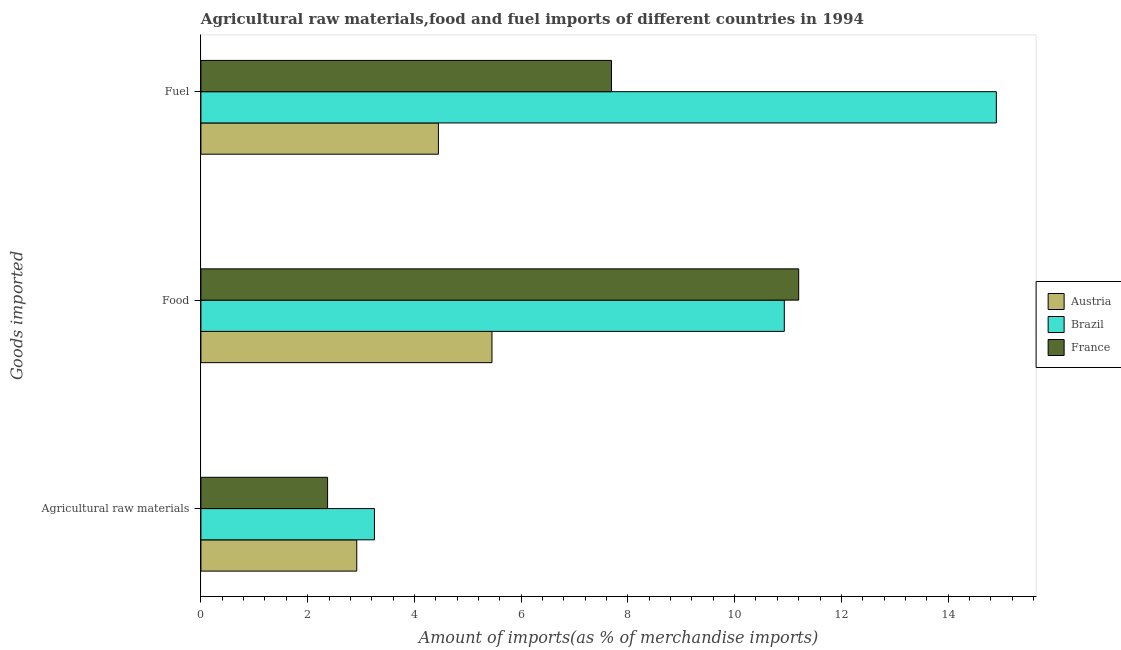How many different coloured bars are there?
Provide a succinct answer. 3. How many groups of bars are there?
Your response must be concise. 3. Are the number of bars on each tick of the Y-axis equal?
Your answer should be very brief. Yes. How many bars are there on the 1st tick from the top?
Offer a very short reply. 3. How many bars are there on the 1st tick from the bottom?
Give a very brief answer. 3. What is the label of the 1st group of bars from the top?
Give a very brief answer. Fuel. What is the percentage of food imports in Brazil?
Offer a very short reply. 10.93. Across all countries, what is the maximum percentage of food imports?
Ensure brevity in your answer.  11.2. Across all countries, what is the minimum percentage of raw materials imports?
Provide a succinct answer. 2.37. In which country was the percentage of food imports maximum?
Keep it short and to the point. France. In which country was the percentage of fuel imports minimum?
Offer a terse response. Austria. What is the total percentage of raw materials imports in the graph?
Make the answer very short. 8.55. What is the difference between the percentage of food imports in France and that in Brazil?
Offer a very short reply. 0.27. What is the difference between the percentage of food imports in France and the percentage of fuel imports in Austria?
Your answer should be compact. 6.75. What is the average percentage of food imports per country?
Give a very brief answer. 9.2. What is the difference between the percentage of food imports and percentage of fuel imports in France?
Provide a succinct answer. 3.51. What is the ratio of the percentage of food imports in Brazil to that in Austria?
Give a very brief answer. 2. Is the percentage of food imports in Brazil less than that in France?
Your response must be concise. Yes. What is the difference between the highest and the second highest percentage of fuel imports?
Ensure brevity in your answer.  7.21. What is the difference between the highest and the lowest percentage of fuel imports?
Provide a succinct answer. 10.45. Is the sum of the percentage of food imports in Brazil and France greater than the maximum percentage of raw materials imports across all countries?
Offer a very short reply. Yes. What does the 2nd bar from the top in Agricultural raw materials represents?
Provide a short and direct response. Brazil. How many bars are there?
Keep it short and to the point. 9. What is the difference between two consecutive major ticks on the X-axis?
Give a very brief answer. 2. Are the values on the major ticks of X-axis written in scientific E-notation?
Provide a short and direct response. No. Does the graph contain any zero values?
Keep it short and to the point. No. Does the graph contain grids?
Your answer should be very brief. No. Where does the legend appear in the graph?
Your answer should be very brief. Center right. How are the legend labels stacked?
Ensure brevity in your answer.  Vertical. What is the title of the graph?
Ensure brevity in your answer.  Agricultural raw materials,food and fuel imports of different countries in 1994. Does "Jordan" appear as one of the legend labels in the graph?
Your answer should be compact. No. What is the label or title of the X-axis?
Make the answer very short. Amount of imports(as % of merchandise imports). What is the label or title of the Y-axis?
Offer a terse response. Goods imported. What is the Amount of imports(as % of merchandise imports) of Austria in Agricultural raw materials?
Your answer should be very brief. 2.92. What is the Amount of imports(as % of merchandise imports) of Brazil in Agricultural raw materials?
Offer a very short reply. 3.25. What is the Amount of imports(as % of merchandise imports) of France in Agricultural raw materials?
Ensure brevity in your answer.  2.37. What is the Amount of imports(as % of merchandise imports) of Austria in Food?
Provide a succinct answer. 5.45. What is the Amount of imports(as % of merchandise imports) of Brazil in Food?
Make the answer very short. 10.93. What is the Amount of imports(as % of merchandise imports) of France in Food?
Your answer should be compact. 11.2. What is the Amount of imports(as % of merchandise imports) of Austria in Fuel?
Provide a short and direct response. 4.45. What is the Amount of imports(as % of merchandise imports) in Brazil in Fuel?
Your response must be concise. 14.9. What is the Amount of imports(as % of merchandise imports) of France in Fuel?
Make the answer very short. 7.69. Across all Goods imported, what is the maximum Amount of imports(as % of merchandise imports) of Austria?
Make the answer very short. 5.45. Across all Goods imported, what is the maximum Amount of imports(as % of merchandise imports) in Brazil?
Your response must be concise. 14.9. Across all Goods imported, what is the maximum Amount of imports(as % of merchandise imports) of France?
Make the answer very short. 11.2. Across all Goods imported, what is the minimum Amount of imports(as % of merchandise imports) of Austria?
Offer a terse response. 2.92. Across all Goods imported, what is the minimum Amount of imports(as % of merchandise imports) in Brazil?
Keep it short and to the point. 3.25. Across all Goods imported, what is the minimum Amount of imports(as % of merchandise imports) in France?
Ensure brevity in your answer.  2.37. What is the total Amount of imports(as % of merchandise imports) of Austria in the graph?
Provide a succinct answer. 12.82. What is the total Amount of imports(as % of merchandise imports) of Brazil in the graph?
Your response must be concise. 29.09. What is the total Amount of imports(as % of merchandise imports) of France in the graph?
Your answer should be compact. 21.27. What is the difference between the Amount of imports(as % of merchandise imports) of Austria in Agricultural raw materials and that in Food?
Keep it short and to the point. -2.53. What is the difference between the Amount of imports(as % of merchandise imports) in Brazil in Agricultural raw materials and that in Food?
Ensure brevity in your answer.  -7.68. What is the difference between the Amount of imports(as % of merchandise imports) of France in Agricultural raw materials and that in Food?
Offer a terse response. -8.83. What is the difference between the Amount of imports(as % of merchandise imports) in Austria in Agricultural raw materials and that in Fuel?
Your answer should be very brief. -1.53. What is the difference between the Amount of imports(as % of merchandise imports) of Brazil in Agricultural raw materials and that in Fuel?
Make the answer very short. -11.65. What is the difference between the Amount of imports(as % of merchandise imports) of France in Agricultural raw materials and that in Fuel?
Offer a very short reply. -5.32. What is the difference between the Amount of imports(as % of merchandise imports) of Austria in Food and that in Fuel?
Offer a terse response. 1. What is the difference between the Amount of imports(as % of merchandise imports) of Brazil in Food and that in Fuel?
Your answer should be compact. -3.97. What is the difference between the Amount of imports(as % of merchandise imports) of France in Food and that in Fuel?
Ensure brevity in your answer.  3.51. What is the difference between the Amount of imports(as % of merchandise imports) in Austria in Agricultural raw materials and the Amount of imports(as % of merchandise imports) in Brazil in Food?
Ensure brevity in your answer.  -8.01. What is the difference between the Amount of imports(as % of merchandise imports) of Austria in Agricultural raw materials and the Amount of imports(as % of merchandise imports) of France in Food?
Offer a terse response. -8.28. What is the difference between the Amount of imports(as % of merchandise imports) in Brazil in Agricultural raw materials and the Amount of imports(as % of merchandise imports) in France in Food?
Your answer should be very brief. -7.95. What is the difference between the Amount of imports(as % of merchandise imports) of Austria in Agricultural raw materials and the Amount of imports(as % of merchandise imports) of Brazil in Fuel?
Make the answer very short. -11.98. What is the difference between the Amount of imports(as % of merchandise imports) in Austria in Agricultural raw materials and the Amount of imports(as % of merchandise imports) in France in Fuel?
Provide a succinct answer. -4.77. What is the difference between the Amount of imports(as % of merchandise imports) in Brazil in Agricultural raw materials and the Amount of imports(as % of merchandise imports) in France in Fuel?
Ensure brevity in your answer.  -4.44. What is the difference between the Amount of imports(as % of merchandise imports) of Austria in Food and the Amount of imports(as % of merchandise imports) of Brazil in Fuel?
Provide a succinct answer. -9.45. What is the difference between the Amount of imports(as % of merchandise imports) of Austria in Food and the Amount of imports(as % of merchandise imports) of France in Fuel?
Your response must be concise. -2.24. What is the difference between the Amount of imports(as % of merchandise imports) of Brazil in Food and the Amount of imports(as % of merchandise imports) of France in Fuel?
Ensure brevity in your answer.  3.24. What is the average Amount of imports(as % of merchandise imports) in Austria per Goods imported?
Your answer should be compact. 4.27. What is the average Amount of imports(as % of merchandise imports) of Brazil per Goods imported?
Provide a short and direct response. 9.7. What is the average Amount of imports(as % of merchandise imports) in France per Goods imported?
Your answer should be compact. 7.09. What is the difference between the Amount of imports(as % of merchandise imports) in Austria and Amount of imports(as % of merchandise imports) in Brazil in Agricultural raw materials?
Make the answer very short. -0.33. What is the difference between the Amount of imports(as % of merchandise imports) of Austria and Amount of imports(as % of merchandise imports) of France in Agricultural raw materials?
Ensure brevity in your answer.  0.55. What is the difference between the Amount of imports(as % of merchandise imports) of Brazil and Amount of imports(as % of merchandise imports) of France in Agricultural raw materials?
Provide a succinct answer. 0.88. What is the difference between the Amount of imports(as % of merchandise imports) in Austria and Amount of imports(as % of merchandise imports) in Brazil in Food?
Make the answer very short. -5.48. What is the difference between the Amount of imports(as % of merchandise imports) of Austria and Amount of imports(as % of merchandise imports) of France in Food?
Make the answer very short. -5.75. What is the difference between the Amount of imports(as % of merchandise imports) of Brazil and Amount of imports(as % of merchandise imports) of France in Food?
Offer a very short reply. -0.27. What is the difference between the Amount of imports(as % of merchandise imports) in Austria and Amount of imports(as % of merchandise imports) in Brazil in Fuel?
Offer a very short reply. -10.45. What is the difference between the Amount of imports(as % of merchandise imports) in Austria and Amount of imports(as % of merchandise imports) in France in Fuel?
Your answer should be compact. -3.24. What is the difference between the Amount of imports(as % of merchandise imports) in Brazil and Amount of imports(as % of merchandise imports) in France in Fuel?
Ensure brevity in your answer.  7.21. What is the ratio of the Amount of imports(as % of merchandise imports) of Austria in Agricultural raw materials to that in Food?
Ensure brevity in your answer.  0.54. What is the ratio of the Amount of imports(as % of merchandise imports) of Brazil in Agricultural raw materials to that in Food?
Ensure brevity in your answer.  0.3. What is the ratio of the Amount of imports(as % of merchandise imports) of France in Agricultural raw materials to that in Food?
Your answer should be compact. 0.21. What is the ratio of the Amount of imports(as % of merchandise imports) of Austria in Agricultural raw materials to that in Fuel?
Offer a terse response. 0.66. What is the ratio of the Amount of imports(as % of merchandise imports) in Brazil in Agricultural raw materials to that in Fuel?
Offer a terse response. 0.22. What is the ratio of the Amount of imports(as % of merchandise imports) in France in Agricultural raw materials to that in Fuel?
Give a very brief answer. 0.31. What is the ratio of the Amount of imports(as % of merchandise imports) of Austria in Food to that in Fuel?
Offer a terse response. 1.23. What is the ratio of the Amount of imports(as % of merchandise imports) in Brazil in Food to that in Fuel?
Your answer should be compact. 0.73. What is the ratio of the Amount of imports(as % of merchandise imports) of France in Food to that in Fuel?
Offer a very short reply. 1.46. What is the difference between the highest and the second highest Amount of imports(as % of merchandise imports) in Brazil?
Offer a terse response. 3.97. What is the difference between the highest and the second highest Amount of imports(as % of merchandise imports) in France?
Provide a succinct answer. 3.51. What is the difference between the highest and the lowest Amount of imports(as % of merchandise imports) in Austria?
Offer a terse response. 2.53. What is the difference between the highest and the lowest Amount of imports(as % of merchandise imports) of Brazil?
Your response must be concise. 11.65. What is the difference between the highest and the lowest Amount of imports(as % of merchandise imports) in France?
Offer a very short reply. 8.83. 